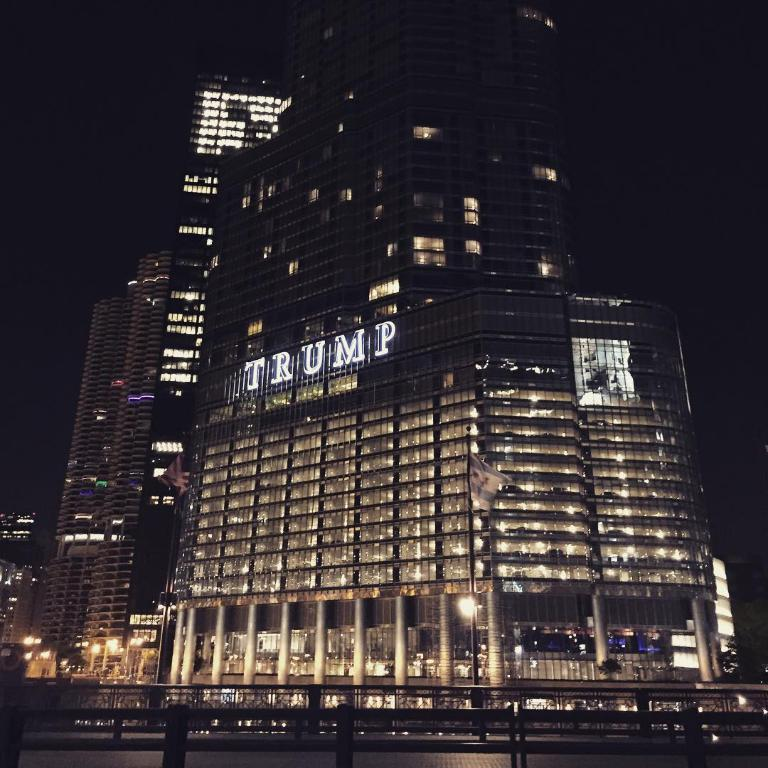<image>
Offer a succinct explanation of the picture presented. A night time photo of Trump Tower all lit up. 